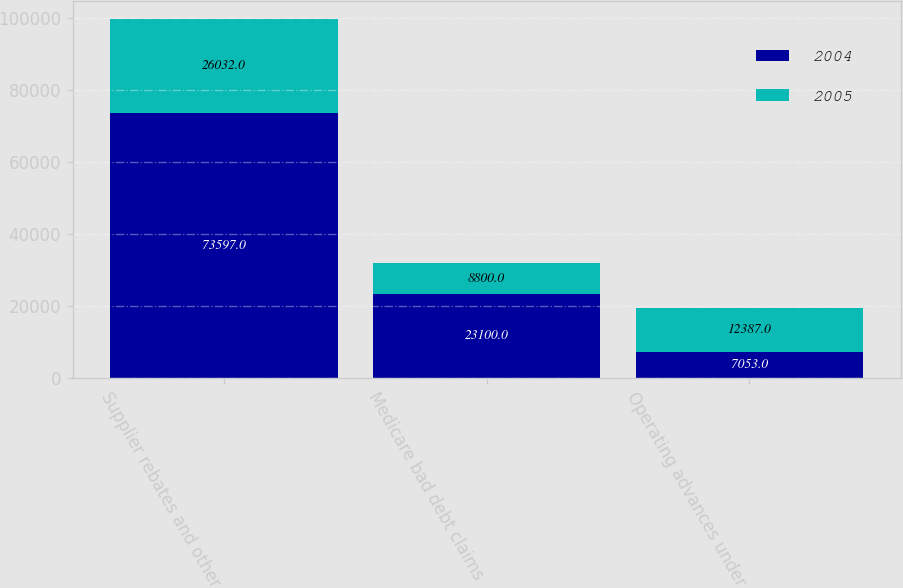<chart> <loc_0><loc_0><loc_500><loc_500><stacked_bar_chart><ecel><fcel>Supplier rebates and other<fcel>Medicare bad debt claims<fcel>Operating advances under<nl><fcel>2004<fcel>73597<fcel>23100<fcel>7053<nl><fcel>2005<fcel>26032<fcel>8800<fcel>12387<nl></chart> 